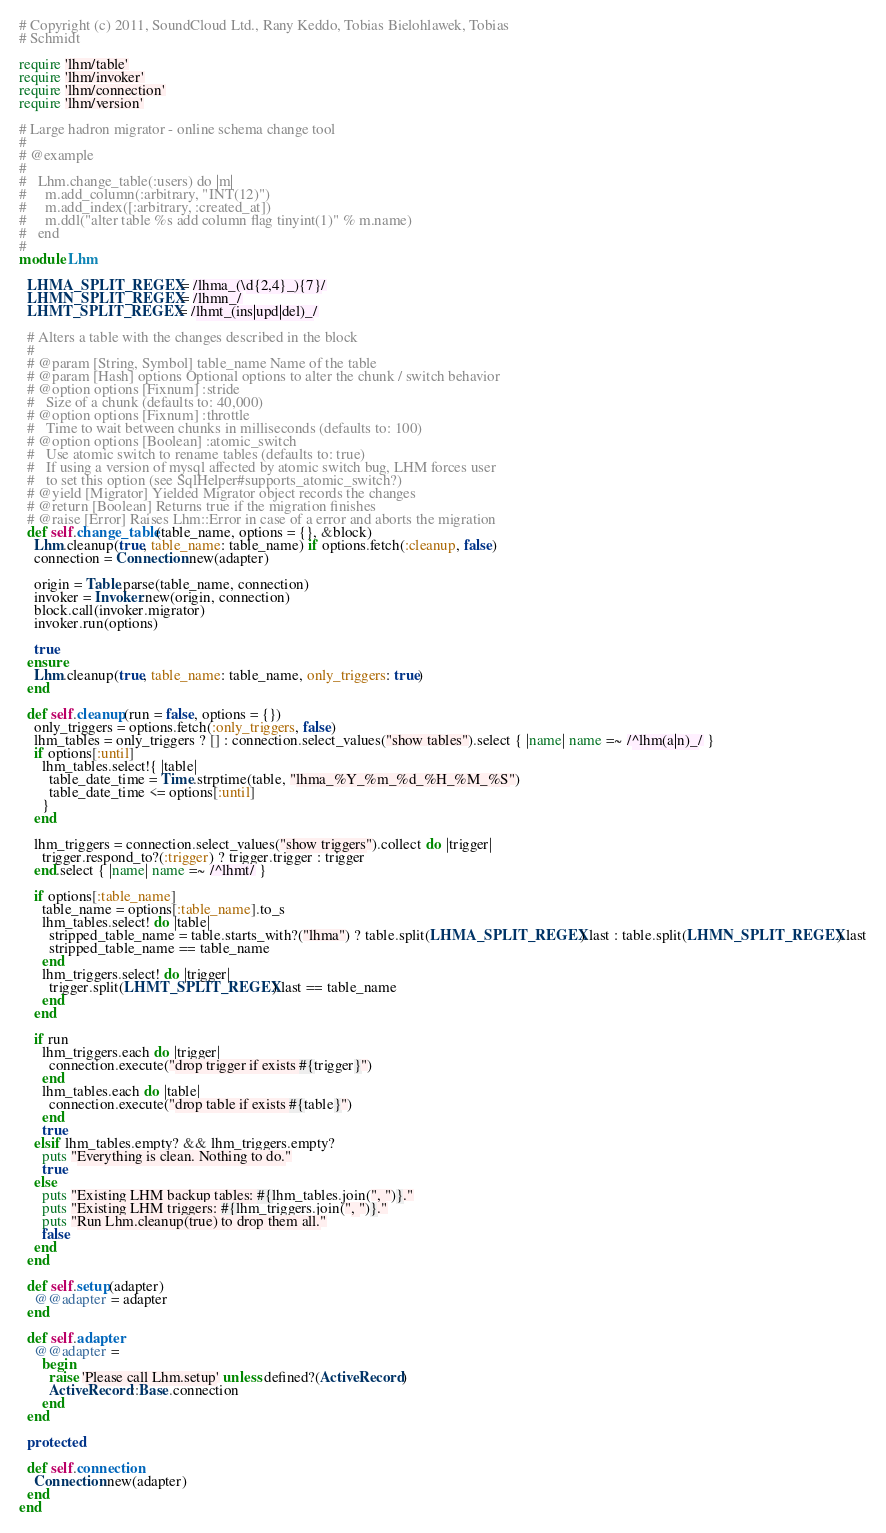Convert code to text. <code><loc_0><loc_0><loc_500><loc_500><_Ruby_># Copyright (c) 2011, SoundCloud Ltd., Rany Keddo, Tobias Bielohlawek, Tobias
# Schmidt

require 'lhm/table'
require 'lhm/invoker'
require 'lhm/connection'
require 'lhm/version'

# Large hadron migrator - online schema change tool
#
# @example
#
#   Lhm.change_table(:users) do |m|
#     m.add_column(:arbitrary, "INT(12)")
#     m.add_index([:arbitrary, :created_at])
#     m.ddl("alter table %s add column flag tinyint(1)" % m.name)
#   end
#
module Lhm

  LHMA_SPLIT_REGEX = /lhma_(\d{2,4}_){7}/
  LHMN_SPLIT_REGEX = /lhmn_/
  LHMT_SPLIT_REGEX = /lhmt_(ins|upd|del)_/

  # Alters a table with the changes described in the block
  #
  # @param [String, Symbol] table_name Name of the table
  # @param [Hash] options Optional options to alter the chunk / switch behavior
  # @option options [Fixnum] :stride
  #   Size of a chunk (defaults to: 40,000)
  # @option options [Fixnum] :throttle
  #   Time to wait between chunks in milliseconds (defaults to: 100)
  # @option options [Boolean] :atomic_switch
  #   Use atomic switch to rename tables (defaults to: true)
  #   If using a version of mysql affected by atomic switch bug, LHM forces user
  #   to set this option (see SqlHelper#supports_atomic_switch?)
  # @yield [Migrator] Yielded Migrator object records the changes
  # @return [Boolean] Returns true if the migration finishes
  # @raise [Error] Raises Lhm::Error in case of a error and aborts the migration
  def self.change_table(table_name, options = {}, &block)
    Lhm.cleanup(true, table_name: table_name) if options.fetch(:cleanup, false)
    connection = Connection.new(adapter)

    origin = Table.parse(table_name, connection)
    invoker = Invoker.new(origin, connection)
    block.call(invoker.migrator)
    invoker.run(options)

    true
  ensure
    Lhm.cleanup(true, table_name: table_name, only_triggers: true)
  end

  def self.cleanup(run = false, options = {})
    only_triggers = options.fetch(:only_triggers, false)
    lhm_tables = only_triggers ? [] : connection.select_values("show tables").select { |name| name =~ /^lhm(a|n)_/ }
    if options[:until]
      lhm_tables.select!{ |table|
        table_date_time = Time.strptime(table, "lhma_%Y_%m_%d_%H_%M_%S")
        table_date_time <= options[:until]
      }
    end

    lhm_triggers = connection.select_values("show triggers").collect do |trigger|
      trigger.respond_to?(:trigger) ? trigger.trigger : trigger
    end.select { |name| name =~ /^lhmt/ }

    if options[:table_name]
      table_name = options[:table_name].to_s
      lhm_tables.select! do |table|
        stripped_table_name = table.starts_with?("lhma") ? table.split(LHMA_SPLIT_REGEX).last : table.split(LHMN_SPLIT_REGEX).last
        stripped_table_name == table_name
      end
      lhm_triggers.select! do |trigger|
        trigger.split(LHMT_SPLIT_REGEX).last == table_name
      end
    end

    if run
      lhm_triggers.each do |trigger|
        connection.execute("drop trigger if exists #{trigger}")
      end
      lhm_tables.each do |table|
        connection.execute("drop table if exists #{table}")
      end
      true
    elsif lhm_tables.empty? && lhm_triggers.empty?
      puts "Everything is clean. Nothing to do."
      true
    else
      puts "Existing LHM backup tables: #{lhm_tables.join(", ")}."
      puts "Existing LHM triggers: #{lhm_triggers.join(", ")}."
      puts "Run Lhm.cleanup(true) to drop them all."
      false
    end
  end

  def self.setup(adapter)
    @@adapter = adapter
  end

  def self.adapter
    @@adapter =
      begin
        raise 'Please call Lhm.setup' unless defined?(ActiveRecord)
        ActiveRecord::Base.connection
      end
  end

  protected

  def self.connection
    Connection.new(adapter)
  end
end
</code> 